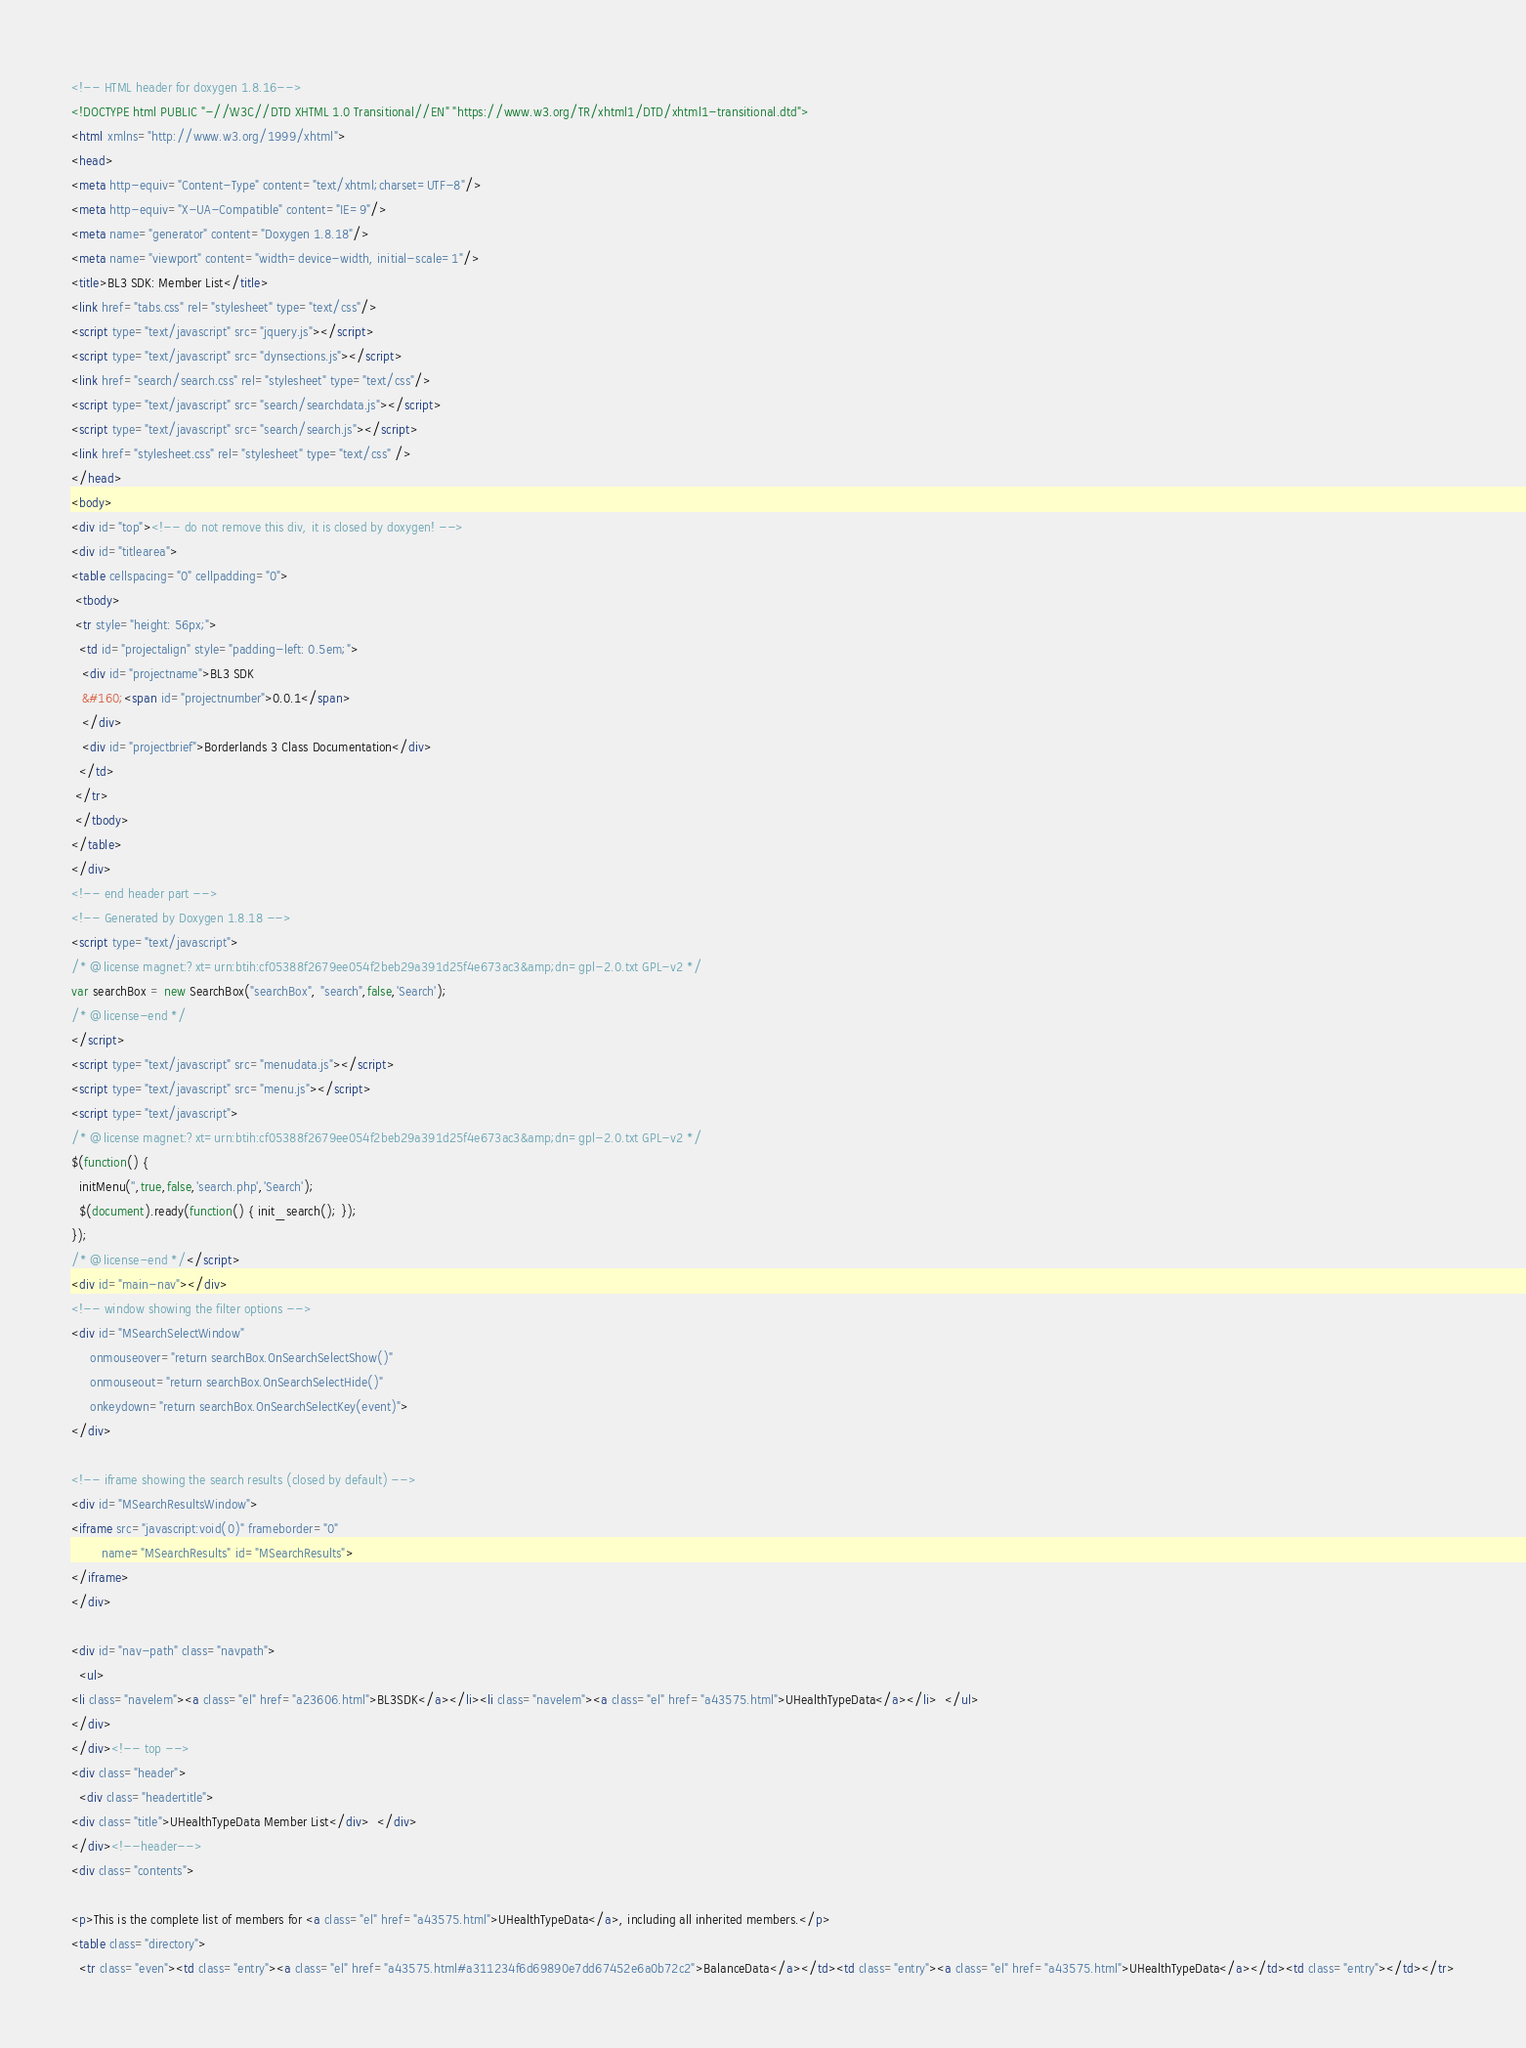<code> <loc_0><loc_0><loc_500><loc_500><_HTML_><!-- HTML header for doxygen 1.8.16-->
<!DOCTYPE html PUBLIC "-//W3C//DTD XHTML 1.0 Transitional//EN" "https://www.w3.org/TR/xhtml1/DTD/xhtml1-transitional.dtd">
<html xmlns="http://www.w3.org/1999/xhtml">
<head>
<meta http-equiv="Content-Type" content="text/xhtml;charset=UTF-8"/>
<meta http-equiv="X-UA-Compatible" content="IE=9"/>
<meta name="generator" content="Doxygen 1.8.18"/>
<meta name="viewport" content="width=device-width, initial-scale=1"/>
<title>BL3 SDK: Member List</title>
<link href="tabs.css" rel="stylesheet" type="text/css"/>
<script type="text/javascript" src="jquery.js"></script>
<script type="text/javascript" src="dynsections.js"></script>
<link href="search/search.css" rel="stylesheet" type="text/css"/>
<script type="text/javascript" src="search/searchdata.js"></script>
<script type="text/javascript" src="search/search.js"></script>
<link href="stylesheet.css" rel="stylesheet" type="text/css" />
</head>
<body>
<div id="top"><!-- do not remove this div, it is closed by doxygen! -->
<div id="titlearea">
<table cellspacing="0" cellpadding="0">
 <tbody>
 <tr style="height: 56px;">
  <td id="projectalign" style="padding-left: 0.5em;">
   <div id="projectname">BL3 SDK
   &#160;<span id="projectnumber">0.0.1</span>
   </div>
   <div id="projectbrief">Borderlands 3 Class Documentation</div>
  </td>
 </tr>
 </tbody>
</table>
</div>
<!-- end header part -->
<!-- Generated by Doxygen 1.8.18 -->
<script type="text/javascript">
/* @license magnet:?xt=urn:btih:cf05388f2679ee054f2beb29a391d25f4e673ac3&amp;dn=gpl-2.0.txt GPL-v2 */
var searchBox = new SearchBox("searchBox", "search",false,'Search');
/* @license-end */
</script>
<script type="text/javascript" src="menudata.js"></script>
<script type="text/javascript" src="menu.js"></script>
<script type="text/javascript">
/* @license magnet:?xt=urn:btih:cf05388f2679ee054f2beb29a391d25f4e673ac3&amp;dn=gpl-2.0.txt GPL-v2 */
$(function() {
  initMenu('',true,false,'search.php','Search');
  $(document).ready(function() { init_search(); });
});
/* @license-end */</script>
<div id="main-nav"></div>
<!-- window showing the filter options -->
<div id="MSearchSelectWindow"
     onmouseover="return searchBox.OnSearchSelectShow()"
     onmouseout="return searchBox.OnSearchSelectHide()"
     onkeydown="return searchBox.OnSearchSelectKey(event)">
</div>

<!-- iframe showing the search results (closed by default) -->
<div id="MSearchResultsWindow">
<iframe src="javascript:void(0)" frameborder="0" 
        name="MSearchResults" id="MSearchResults">
</iframe>
</div>

<div id="nav-path" class="navpath">
  <ul>
<li class="navelem"><a class="el" href="a23606.html">BL3SDK</a></li><li class="navelem"><a class="el" href="a43575.html">UHealthTypeData</a></li>  </ul>
</div>
</div><!-- top -->
<div class="header">
  <div class="headertitle">
<div class="title">UHealthTypeData Member List</div>  </div>
</div><!--header-->
<div class="contents">

<p>This is the complete list of members for <a class="el" href="a43575.html">UHealthTypeData</a>, including all inherited members.</p>
<table class="directory">
  <tr class="even"><td class="entry"><a class="el" href="a43575.html#a311234f6d69890e7dd67452e6a0b72c2">BalanceData</a></td><td class="entry"><a class="el" href="a43575.html">UHealthTypeData</a></td><td class="entry"></td></tr></code> 